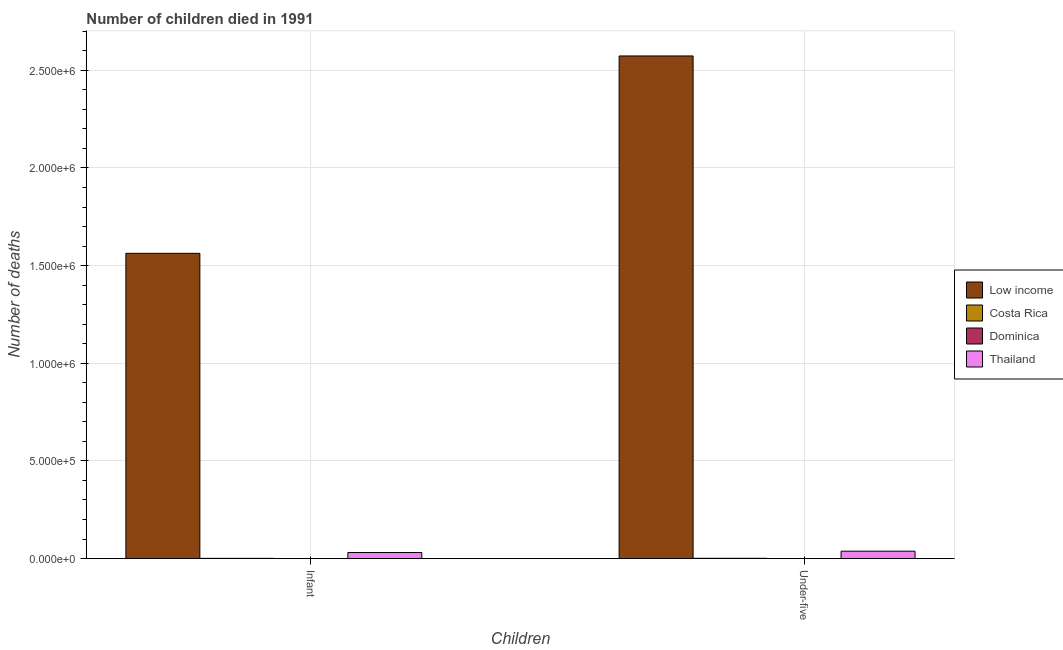Are the number of bars per tick equal to the number of legend labels?
Ensure brevity in your answer.  Yes. How many bars are there on the 1st tick from the right?
Keep it short and to the point. 4. What is the label of the 1st group of bars from the left?
Provide a succinct answer. Infant. What is the number of under-five deaths in Low income?
Provide a succinct answer. 2.57e+06. Across all countries, what is the maximum number of under-five deaths?
Your answer should be compact. 2.57e+06. Across all countries, what is the minimum number of infant deaths?
Ensure brevity in your answer.  17. In which country was the number of infant deaths maximum?
Your answer should be compact. Low income. In which country was the number of under-five deaths minimum?
Your response must be concise. Dominica. What is the total number of under-five deaths in the graph?
Keep it short and to the point. 2.61e+06. What is the difference between the number of infant deaths in Dominica and that in Low income?
Give a very brief answer. -1.56e+06. What is the difference between the number of under-five deaths in Low income and the number of infant deaths in Thailand?
Offer a terse response. 2.54e+06. What is the average number of infant deaths per country?
Your answer should be very brief. 3.99e+05. What is the difference between the number of infant deaths and number of under-five deaths in Costa Rica?
Give a very brief answer. -204. In how many countries, is the number of under-five deaths greater than 100000 ?
Your answer should be compact. 1. What is the ratio of the number of infant deaths in Dominica to that in Costa Rica?
Ensure brevity in your answer.  0.01. In how many countries, is the number of infant deaths greater than the average number of infant deaths taken over all countries?
Provide a short and direct response. 1. What does the 4th bar from the right in Infant represents?
Give a very brief answer. Low income. What is the difference between two consecutive major ticks on the Y-axis?
Offer a very short reply. 5.00e+05. How many legend labels are there?
Your response must be concise. 4. What is the title of the graph?
Offer a very short reply. Number of children died in 1991. What is the label or title of the X-axis?
Give a very brief answer. Children. What is the label or title of the Y-axis?
Provide a succinct answer. Number of deaths. What is the Number of deaths of Low income in Infant?
Your answer should be compact. 1.56e+06. What is the Number of deaths of Costa Rica in Infant?
Ensure brevity in your answer.  1150. What is the Number of deaths in Dominica in Infant?
Make the answer very short. 17. What is the Number of deaths in Thailand in Infant?
Offer a terse response. 3.10e+04. What is the Number of deaths of Low income in Under-five?
Make the answer very short. 2.57e+06. What is the Number of deaths of Costa Rica in Under-five?
Keep it short and to the point. 1354. What is the Number of deaths in Thailand in Under-five?
Your answer should be very brief. 3.78e+04. Across all Children, what is the maximum Number of deaths in Low income?
Ensure brevity in your answer.  2.57e+06. Across all Children, what is the maximum Number of deaths in Costa Rica?
Keep it short and to the point. 1354. Across all Children, what is the maximum Number of deaths in Dominica?
Provide a succinct answer. 21. Across all Children, what is the maximum Number of deaths in Thailand?
Offer a very short reply. 3.78e+04. Across all Children, what is the minimum Number of deaths in Low income?
Provide a succinct answer. 1.56e+06. Across all Children, what is the minimum Number of deaths in Costa Rica?
Offer a very short reply. 1150. Across all Children, what is the minimum Number of deaths in Dominica?
Provide a short and direct response. 17. Across all Children, what is the minimum Number of deaths of Thailand?
Offer a very short reply. 3.10e+04. What is the total Number of deaths of Low income in the graph?
Your response must be concise. 4.14e+06. What is the total Number of deaths of Costa Rica in the graph?
Give a very brief answer. 2504. What is the total Number of deaths in Dominica in the graph?
Provide a short and direct response. 38. What is the total Number of deaths of Thailand in the graph?
Ensure brevity in your answer.  6.88e+04. What is the difference between the Number of deaths of Low income in Infant and that in Under-five?
Offer a very short reply. -1.01e+06. What is the difference between the Number of deaths of Costa Rica in Infant and that in Under-five?
Make the answer very short. -204. What is the difference between the Number of deaths in Thailand in Infant and that in Under-five?
Provide a succinct answer. -6828. What is the difference between the Number of deaths of Low income in Infant and the Number of deaths of Costa Rica in Under-five?
Your answer should be very brief. 1.56e+06. What is the difference between the Number of deaths of Low income in Infant and the Number of deaths of Dominica in Under-five?
Make the answer very short. 1.56e+06. What is the difference between the Number of deaths of Low income in Infant and the Number of deaths of Thailand in Under-five?
Your answer should be very brief. 1.53e+06. What is the difference between the Number of deaths of Costa Rica in Infant and the Number of deaths of Dominica in Under-five?
Your response must be concise. 1129. What is the difference between the Number of deaths in Costa Rica in Infant and the Number of deaths in Thailand in Under-five?
Ensure brevity in your answer.  -3.67e+04. What is the difference between the Number of deaths of Dominica in Infant and the Number of deaths of Thailand in Under-five?
Keep it short and to the point. -3.78e+04. What is the average Number of deaths of Low income per Children?
Offer a terse response. 2.07e+06. What is the average Number of deaths in Costa Rica per Children?
Your answer should be very brief. 1252. What is the average Number of deaths in Thailand per Children?
Keep it short and to the point. 3.44e+04. What is the difference between the Number of deaths in Low income and Number of deaths in Costa Rica in Infant?
Give a very brief answer. 1.56e+06. What is the difference between the Number of deaths of Low income and Number of deaths of Dominica in Infant?
Offer a terse response. 1.56e+06. What is the difference between the Number of deaths of Low income and Number of deaths of Thailand in Infant?
Give a very brief answer. 1.53e+06. What is the difference between the Number of deaths of Costa Rica and Number of deaths of Dominica in Infant?
Provide a succinct answer. 1133. What is the difference between the Number of deaths of Costa Rica and Number of deaths of Thailand in Infant?
Your answer should be compact. -2.98e+04. What is the difference between the Number of deaths of Dominica and Number of deaths of Thailand in Infant?
Offer a very short reply. -3.10e+04. What is the difference between the Number of deaths in Low income and Number of deaths in Costa Rica in Under-five?
Offer a terse response. 2.57e+06. What is the difference between the Number of deaths in Low income and Number of deaths in Dominica in Under-five?
Give a very brief answer. 2.57e+06. What is the difference between the Number of deaths in Low income and Number of deaths in Thailand in Under-five?
Offer a terse response. 2.54e+06. What is the difference between the Number of deaths of Costa Rica and Number of deaths of Dominica in Under-five?
Your answer should be very brief. 1333. What is the difference between the Number of deaths in Costa Rica and Number of deaths in Thailand in Under-five?
Your response must be concise. -3.65e+04. What is the difference between the Number of deaths of Dominica and Number of deaths of Thailand in Under-five?
Ensure brevity in your answer.  -3.78e+04. What is the ratio of the Number of deaths in Low income in Infant to that in Under-five?
Ensure brevity in your answer.  0.61. What is the ratio of the Number of deaths in Costa Rica in Infant to that in Under-five?
Make the answer very short. 0.85. What is the ratio of the Number of deaths in Dominica in Infant to that in Under-five?
Offer a very short reply. 0.81. What is the ratio of the Number of deaths in Thailand in Infant to that in Under-five?
Your answer should be very brief. 0.82. What is the difference between the highest and the second highest Number of deaths of Low income?
Make the answer very short. 1.01e+06. What is the difference between the highest and the second highest Number of deaths in Costa Rica?
Provide a short and direct response. 204. What is the difference between the highest and the second highest Number of deaths of Thailand?
Provide a short and direct response. 6828. What is the difference between the highest and the lowest Number of deaths in Low income?
Your response must be concise. 1.01e+06. What is the difference between the highest and the lowest Number of deaths in Costa Rica?
Ensure brevity in your answer.  204. What is the difference between the highest and the lowest Number of deaths in Thailand?
Keep it short and to the point. 6828. 